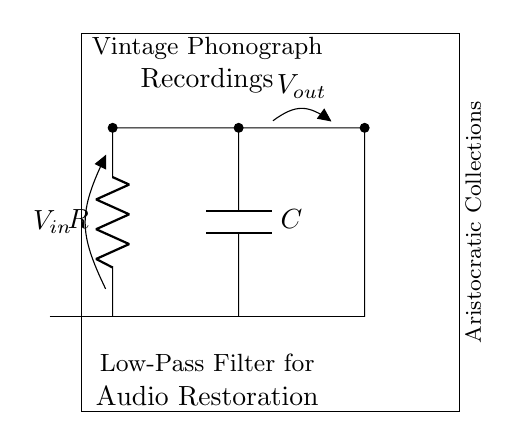What components are in this circuit? The circuit contains a resistor and a capacitor, which are the fundamental components of a low-pass filter. The resistor is labeled as R and the capacitor as C.
Answer: Resistor, Capacitor What voltage is supplied to the input? The voltage supplied to the input is denoted as Vin in the circuit diagram, indicating the input voltage at the beginning of the circuit.
Answer: Vin What is the purpose of this circuit? The purpose of the circuit is to serve as a low-pass filter for audio restoration, specifically aimed at enhancing vintage phonograph recordings.
Answer: Low-pass filter How many nodes are present in the circuit? There are four primary nodes present in this circuit: the input node, output node, and two connections associated with the capacitor and resistor. Each of these represents a junction where current can flow.
Answer: Four Why is this circuit classified as a low-pass filter? A low-pass filter is characterized by allowing low-frequency signals to pass while attenuating high-frequency signals. The resistor-capacitor arrangement creates a frequency-dependent reaction where higher frequencies are shunted to ground by the capacitor.
Answer: Frequency-dependent reaction What type of connection does the resistor have with the capacitor? The resistor is in series with the capacitor in this circuit, meaning the current must flow through the resistor before reaching the capacitor.
Answer: Series connection What type of input would you expect this low-pass filter to process? This low-pass filter is likely to process audio signals, particularly those from vintage phonograph recordings, which consist of low-frequency audio components.
Answer: Audio signals 